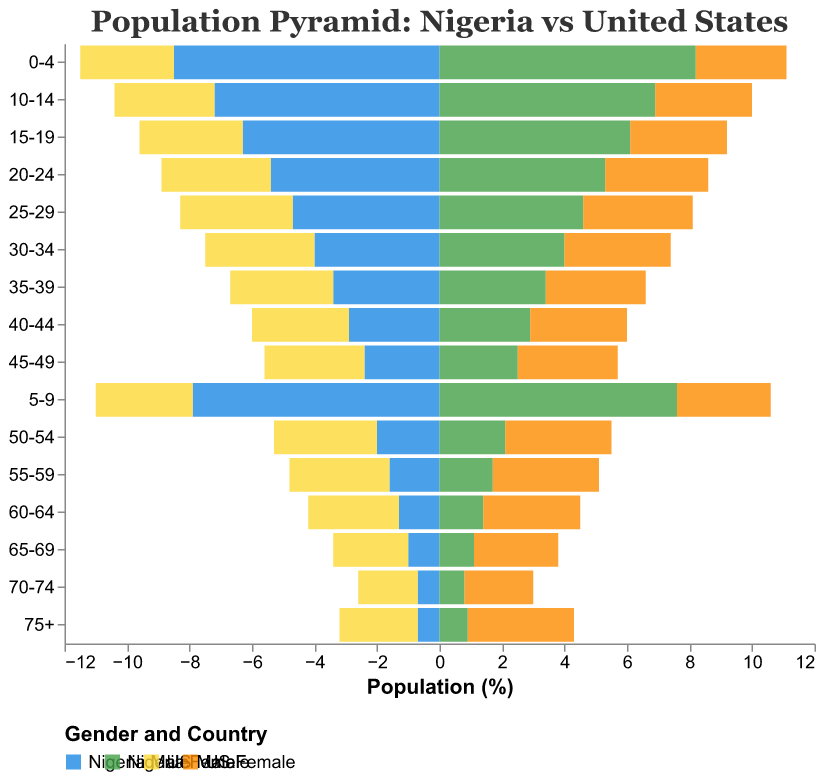What is the title of the figure? The title is usually located at the top of the figure. It provides a brief description of what the figure represents.
Answer: "Population Pyramid: Nigeria vs United States" Which age group has the largest percentage of population in Nigeria? By examining the height (or length) of the bars, we see that the 0-4 age group has the largest percentage for both Nigeria males (8.5%) and females (8.2%).
Answer: 0-4 What is the population percentage for US males in the 25-29 age group? Look for the 25-29 age group on the y-axis and check the length of the corresponding bar for US males, which is depicted in a specific color.
Answer: 3.6% How do the population percentages for Nigeria females and US females in the 75+ age group compare? Compare the bar lengths for Nigeria females (0.9%) and US females (3.4%) in the 75+ age group.
Answer: Nigeria females: 0.9%, US females: 3.4% What is the difference in population percentage between Nigeria males and US males for the 55-59 age group? Subtract the percentage of US males (3.2%) from Nigeria males (1.6%) in the 55-59 age group.
Answer: 1.6% In which age group does the US have the highest percentage of females? Locate the longest bar for US females across all age groups and read its label.
Answer: 75+ How does the population distribution for Nigeria males differ from that for US males in the 30-34 age group? Compare the bar lengths for Nigeria males (4.0%) and US males (3.5%) in the 30-34 age group to see which one is larger.
Answer: Nigeria males: 4.0%, US males: 3.5% What trend can you observe about the Nigerian population as age increases? Noticing the general shape of the bars for Nigeria, the population percentages decrease as the age groups increase, indicating a larger younger population.
Answer: Decreasing trend with age Which country's sex ratio appears more balanced across all age groups? Examine the relative bar lengths of males and females within each country across all age groups to see which country shows less discrepancy between sexes.
Answer: United States What is the combined population percentage for Nigeria in the 20-24 age group? Add the population percentages for Nigeria males (5.4%) and females (5.3%) in the 20-24 age group.
Answer: 10.7% 